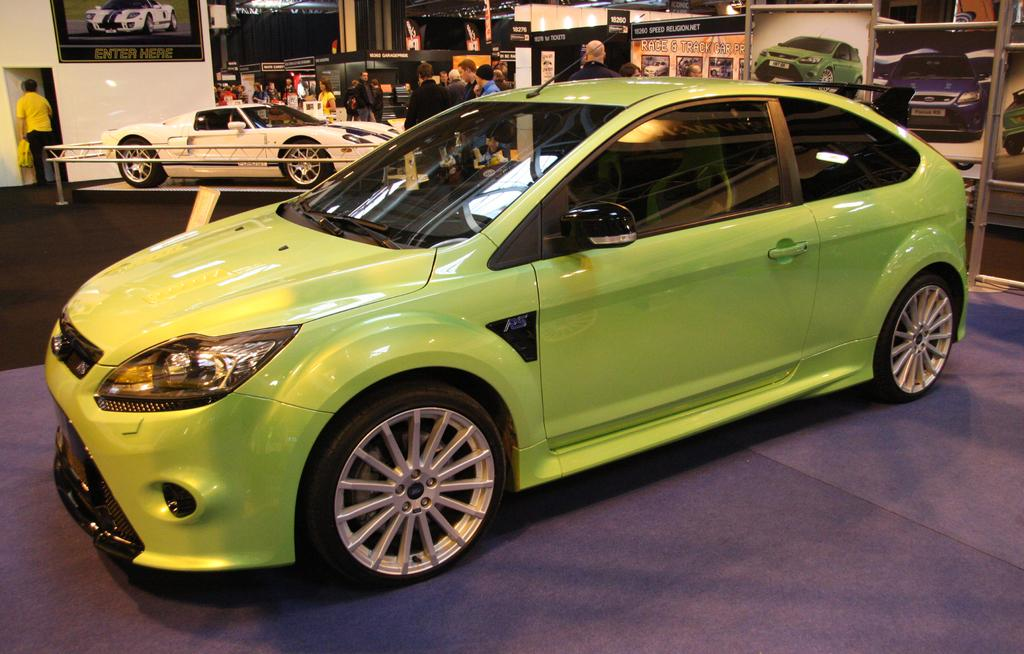What types of vehicles are in the image? There are different colored cars in the image. What else can be seen in the image besides the cars? There are banners and people visible in the image. What is the background of the image? There is a wall in the image. What reward is being given to the person in the image? There is no reward being given in the image; it only shows cars, banners, and people. What cause is being promoted in the image? There is no specific cause mentioned or promoted in the image. 